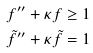<formula> <loc_0><loc_0><loc_500><loc_500>f ^ { \prime \prime } + \kappa f & \geq 1 \\ \tilde { f } ^ { \prime \prime } + \kappa \tilde { f } & = 1</formula> 